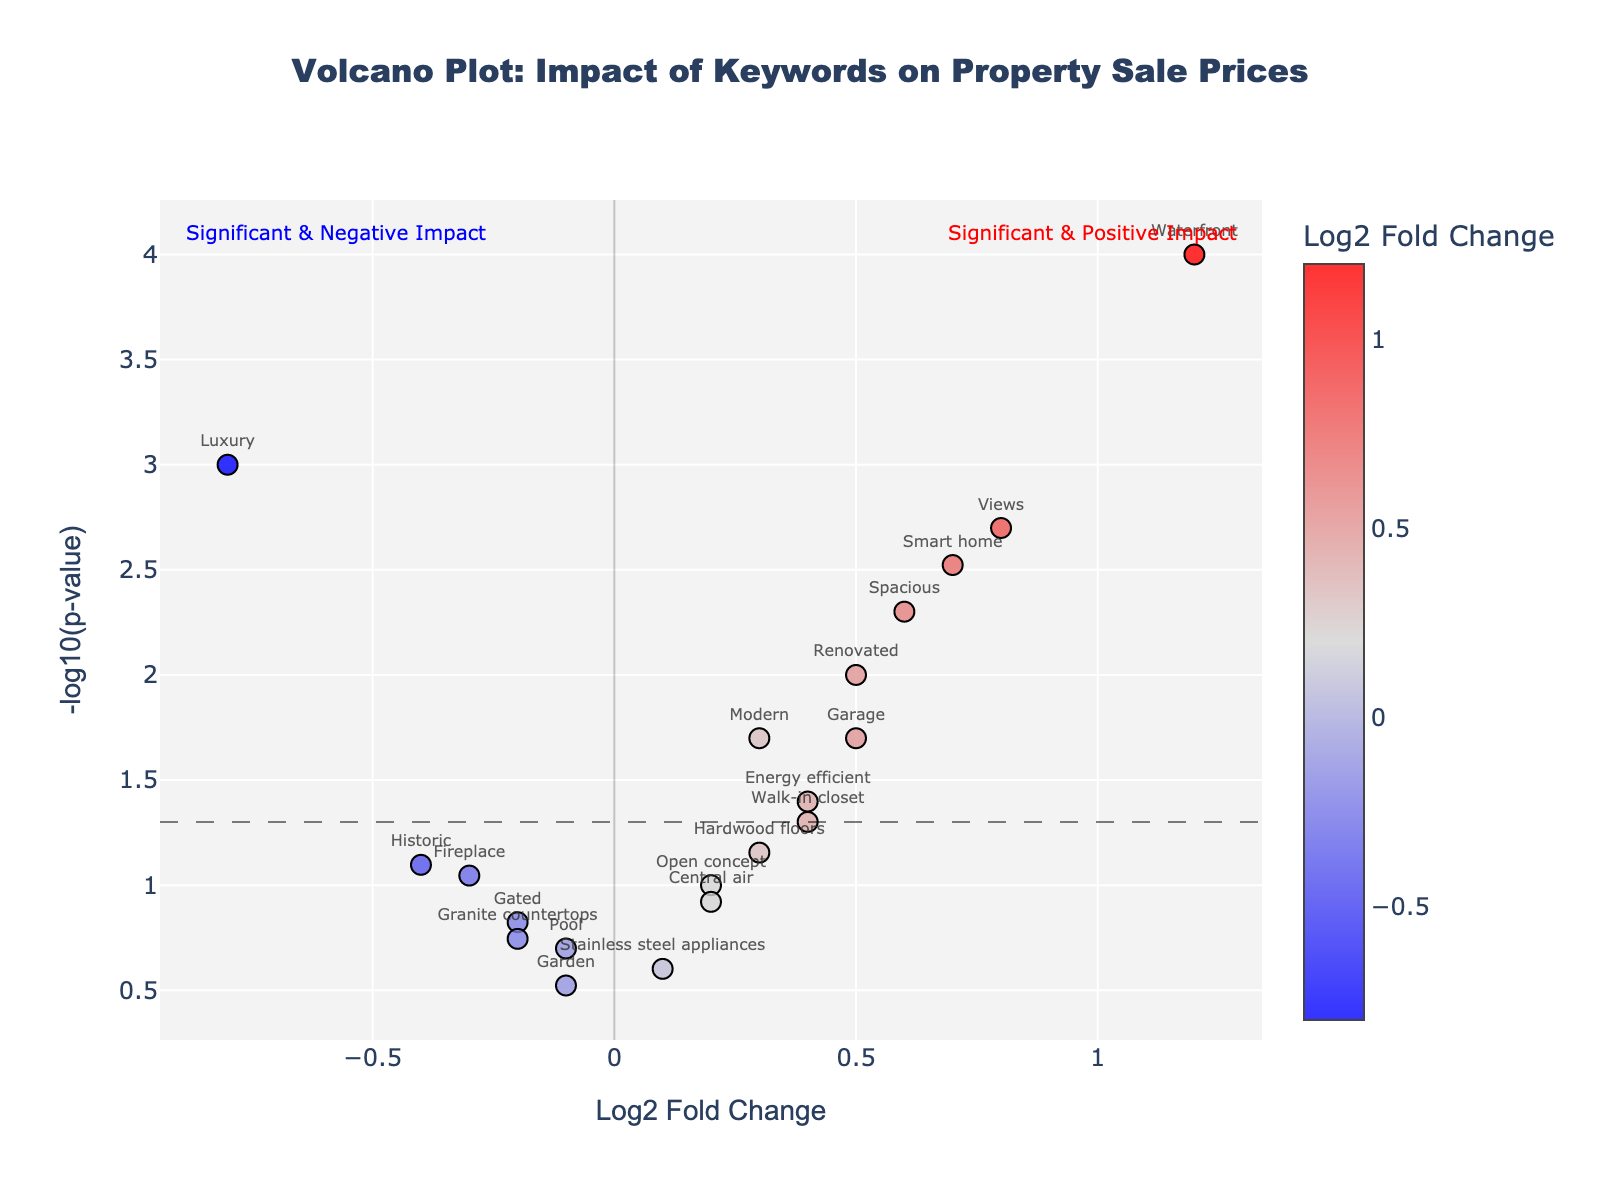What is the title of the figure? The title can be seen at the top of the volcano plot.
Answer: Volcano Plot: Impact of Keywords on Property Sale Prices What do the x-axis and y-axis represent? The x-axis represents the Log2 Fold Change of keywords, and the y-axis represents the -log10 of the p-value.
Answer: Log2 Fold Change, -log10(p-value) Which keyword has the highest positive Log2 Fold Change? Find the data point farthest to the right on the x-axis. The keyword "Waterfront" has this highest positive Log2 Fold Change.
Answer: Waterfront Which keyword has the smallest p-value? Look for the highest point on the y-axis. The keyword "Waterfront" is the highest, indicating the smallest p-value.
Answer: Waterfront Where is the significance threshold line set? The horizontal line runs across the plot, it represents a p-value of 0.05, which corresponds to -log10(p-value) = 1.3.
Answer: 1.3 Which keywords have a statistically significant positive impact on property sale prices? Keywords with -log10(p-value) above 1.3 and positive Log2 Fold Change are considered. These include "Waterfront," "Views", "Smart home", "Spacious", and "Renovated".
Answer: Waterfront, Views, Smart home, Spacious, Renovated How many keywords are above the significance threshold? Count the number of data points above the line at y = 1.3.
Answer: 8 What does it mean when a keyword is positioned in the bottom right corner of the plot? It's an indication of a high positive Log2 Fold Change but a large p-value (low statistical significance).
Answer: High positive Log2 Fold Change, low significance Compare the Log2 Fold Change of "Luxury" and "Energy efficient." Which has a greater impact on decreasing property prices? The keyword "Luxury" has a more negative Log2 Fold Change (-0.8) compared to "Energy efficient" (0.4).
Answer: Luxury What color represents keywords with negative Log2 Fold Change? Look to the left half of the plot where the negative Log2 Fold Change values are located, and they have a color ranging from blue to gray.
Answer: Blue 